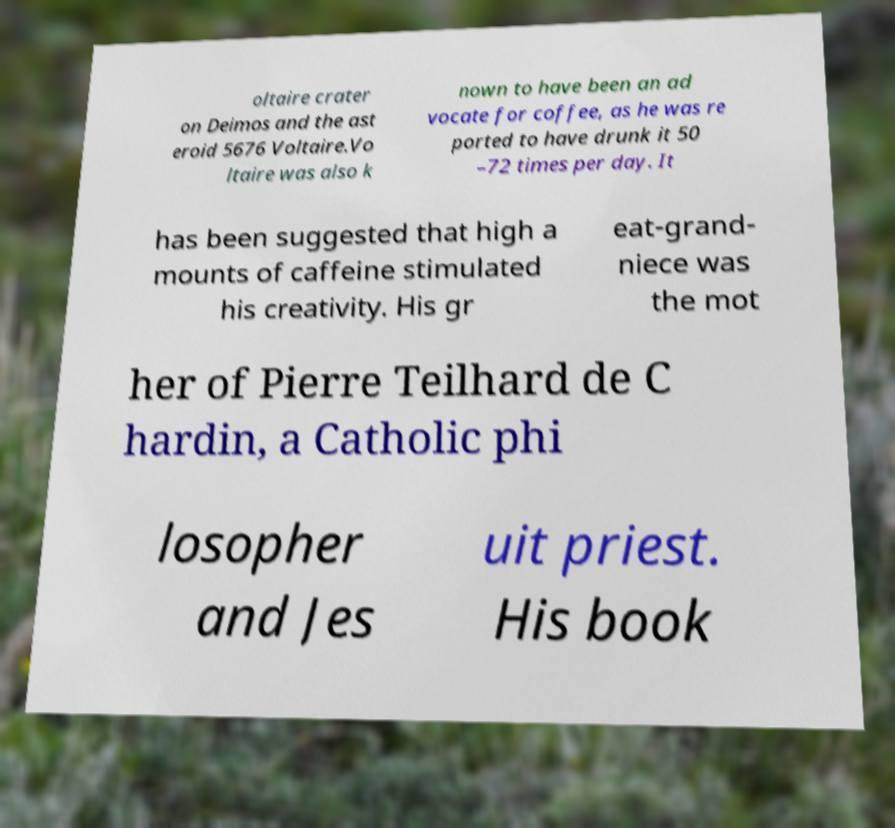What messages or text are displayed in this image? I need them in a readable, typed format. oltaire crater on Deimos and the ast eroid 5676 Voltaire.Vo ltaire was also k nown to have been an ad vocate for coffee, as he was re ported to have drunk it 50 –72 times per day. It has been suggested that high a mounts of caffeine stimulated his creativity. His gr eat-grand- niece was the mot her of Pierre Teilhard de C hardin, a Catholic phi losopher and Jes uit priest. His book 